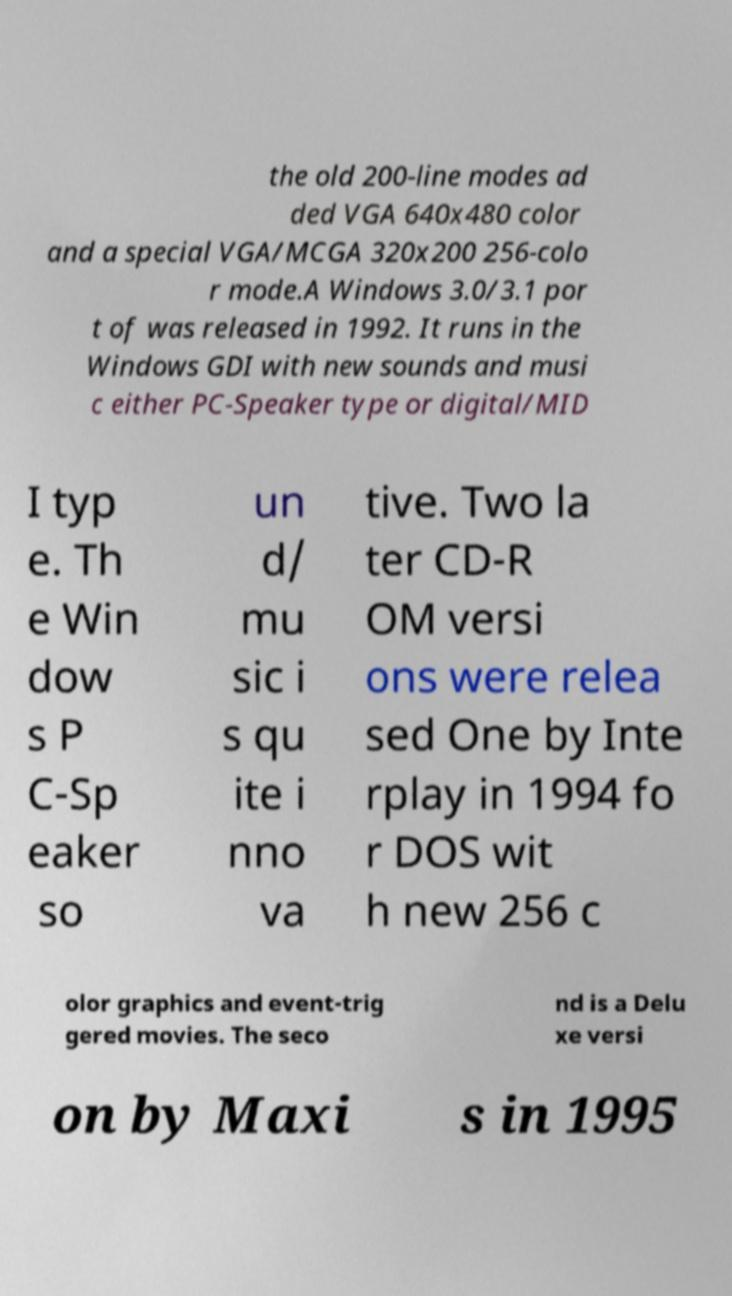Can you accurately transcribe the text from the provided image for me? the old 200-line modes ad ded VGA 640x480 color and a special VGA/MCGA 320x200 256-colo r mode.A Windows 3.0/3.1 por t of was released in 1992. It runs in the Windows GDI with new sounds and musi c either PC-Speaker type or digital/MID I typ e. Th e Win dow s P C-Sp eaker so un d/ mu sic i s qu ite i nno va tive. Two la ter CD-R OM versi ons were relea sed One by Inte rplay in 1994 fo r DOS wit h new 256 c olor graphics and event-trig gered movies. The seco nd is a Delu xe versi on by Maxi s in 1995 